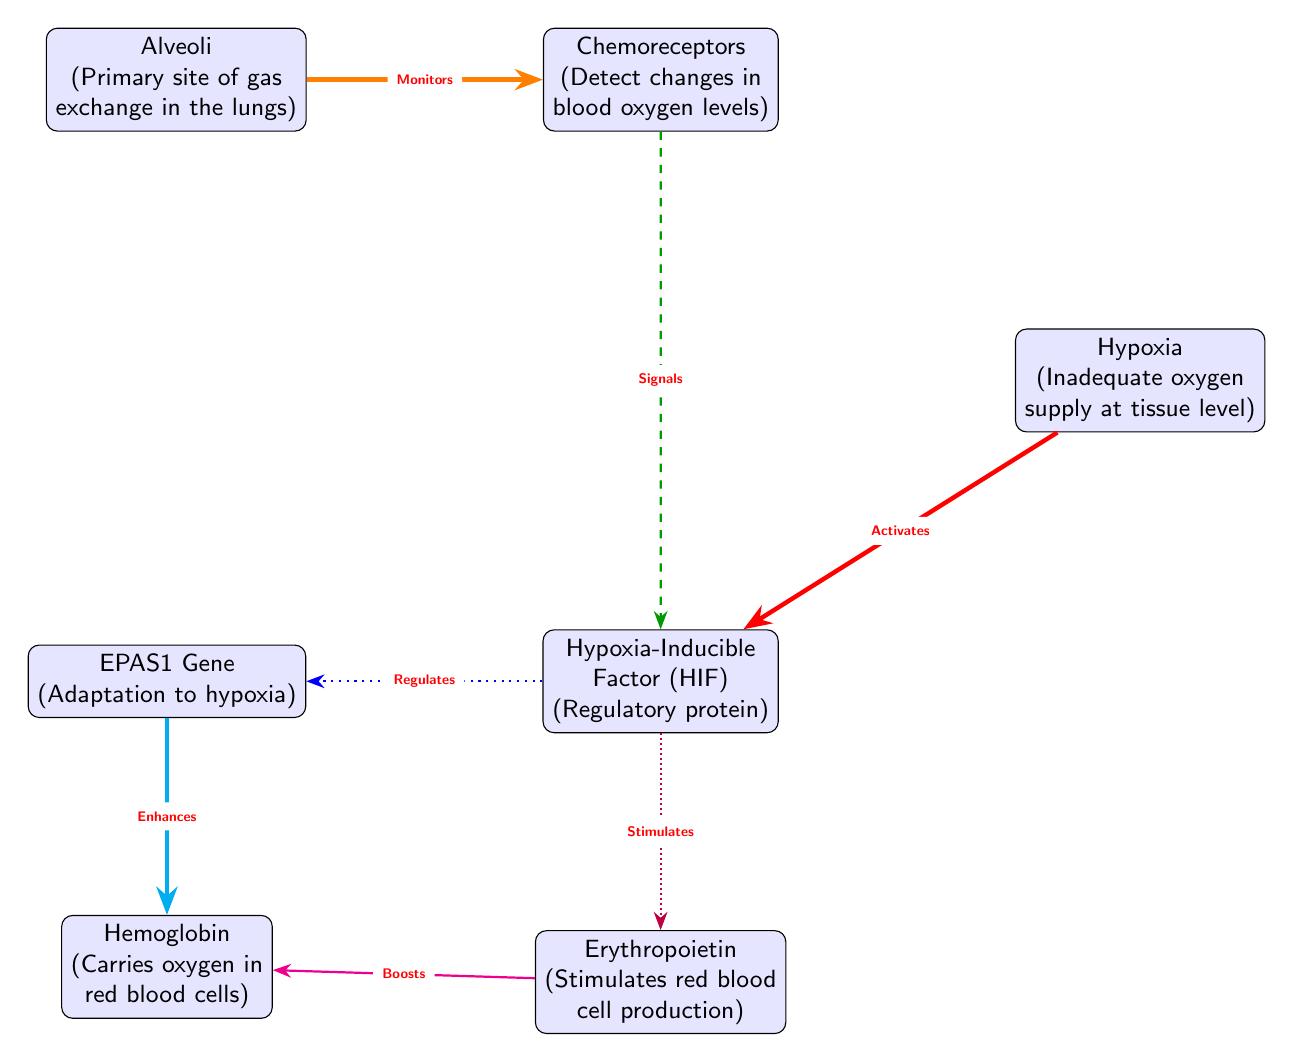What is the primary site of gas exchange in the lungs? The diagram identifies "Alveoli" as the primary site of gas exchange, indicated in the node description.
Answer: Alveoli What regulatory protein is activated by hypoxia? The diagram shows that "Hypoxia" activates the "Hypoxia-Inducible Factor (HIF)" node, which indicates the relationship.
Answer: Hypoxia-Inducible Factor (HIF) How many edges are there in the diagram? By counting the connections between the nodes, we find there are a total of 7 edges as indicated in the diagram.
Answer: 7 What enhances the production of hemoglobin? According to the diagram, "EPAS1 Gene" enhances the production of "Hemoglobin", which is specified by the connecting edge.
Answer: EPAS1 Gene What does erythropoietin stimulate? The diagram specifies that "Erythropoietin" stimulates the production of "red blood cell" which is denoted in its description node.
Answer: Red blood cell production Which node signals HIF from chemoreceptors? The diagram connects "Chemoreceptors" to "Hypoxia-Inducible Factor (HIF)" with a dashed edge labeled "Signals", indicating the flow of information.
Answer: Hypoxia-Inducible Factor (HIF) What effect does hypoxia have on HIF regulation? The diagram shows a strong relationship where "Hypoxia" activates "HIF", indicated by the red, ultra-thick edge. This demonstrates hypoxia's direct activating effect on HIF.
Answer: Activates What is the role of chemorceptors in relation to the alveoli? The diagram indicates that "Alveoli" monitors the "Chemoreceptors", showing the interactive function of sensing oxygen levels in relation to gas exchange.
Answer: Monitors What does HIF stimulate aside from EPAS1? The diagram indicates that "HIF" stimulates "Erythropoietin", making it a relevant connection that contributes to the body's adaptive response to low oxygen levels.
Answer: Erythropoietin 